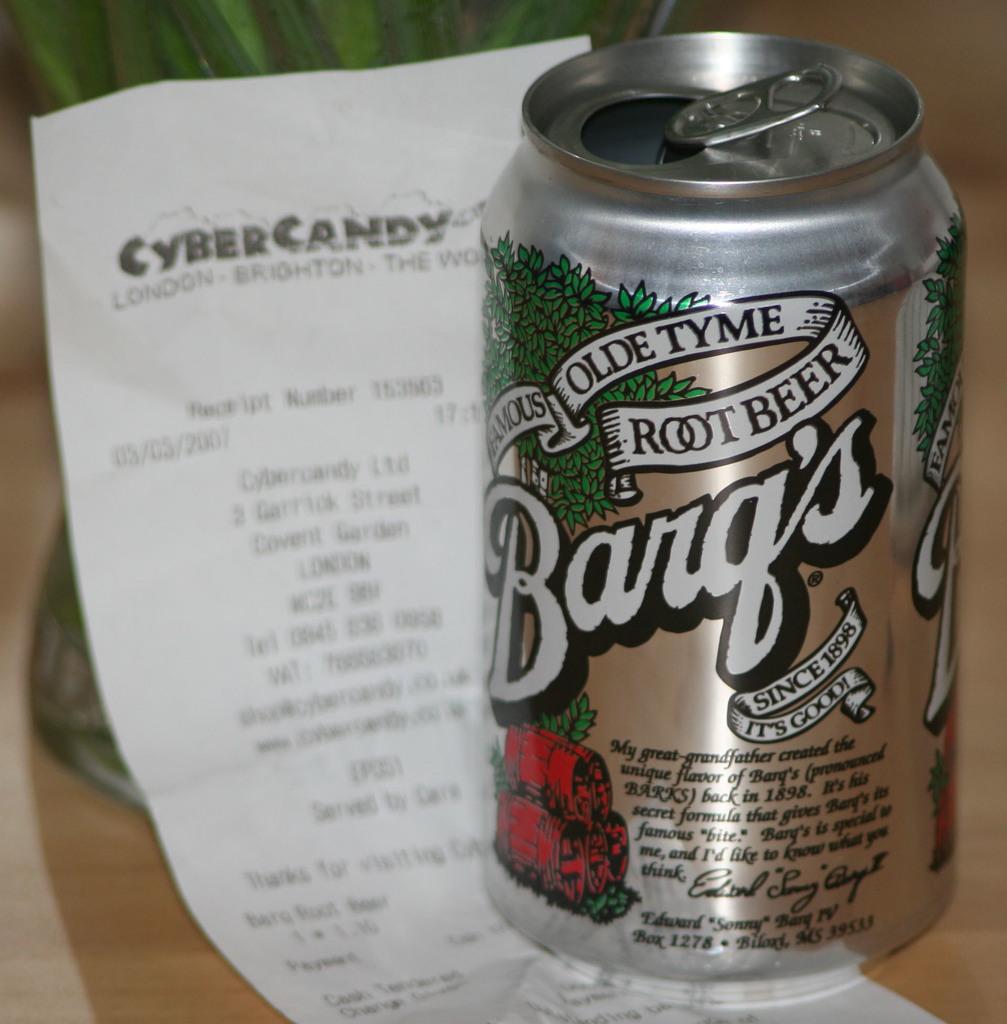What country is on the receipt?
Make the answer very short. London. 